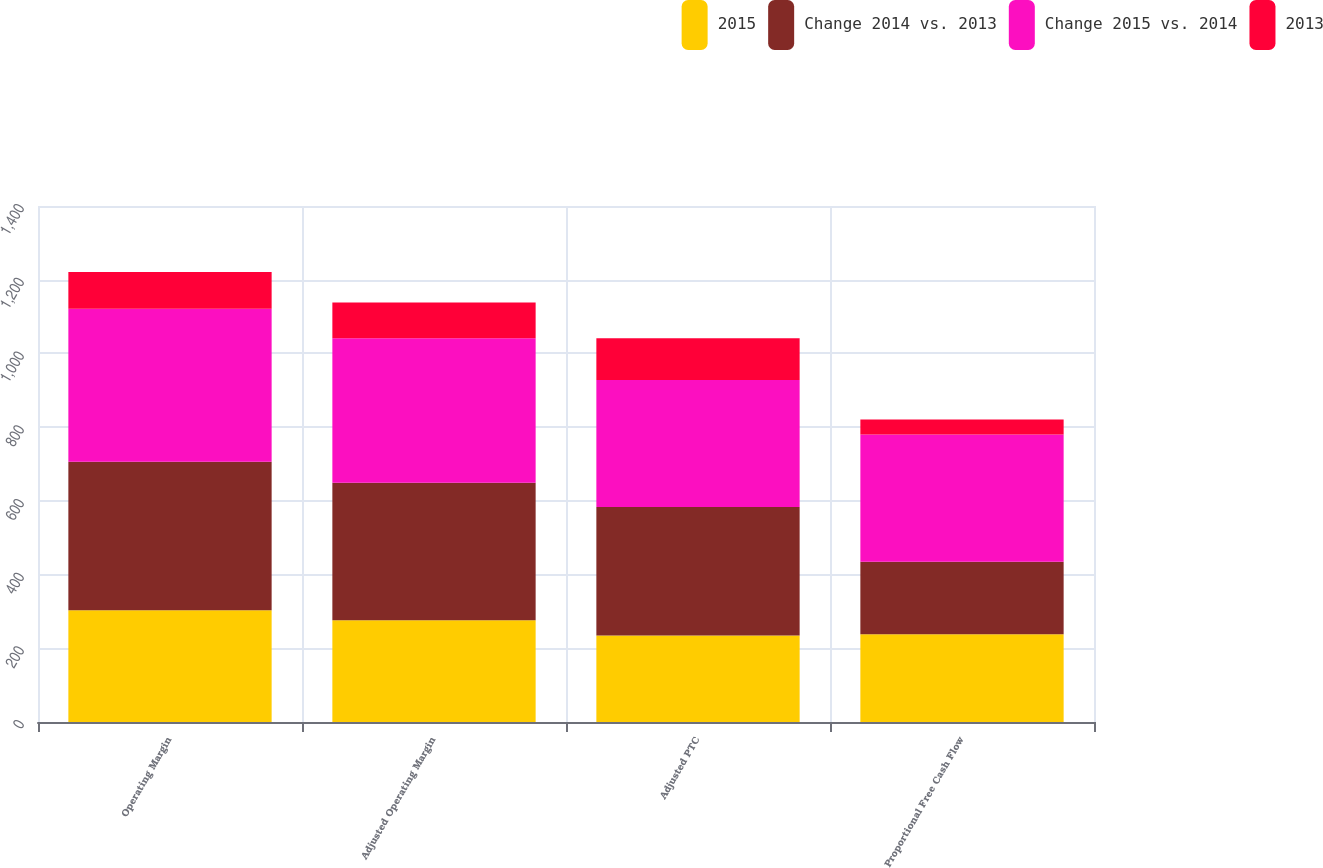Convert chart. <chart><loc_0><loc_0><loc_500><loc_500><stacked_bar_chart><ecel><fcel>Operating Margin<fcel>Adjusted Operating Margin<fcel>Adjusted PTC<fcel>Proportional Free Cash Flow<nl><fcel>2015<fcel>303<fcel>276<fcel>235<fcel>238<nl><fcel>Change 2014 vs. 2013<fcel>403<fcel>373<fcel>348<fcel>197<nl><fcel>Change 2015 vs. 2014<fcel>415<fcel>392<fcel>345<fcel>345<nl><fcel>2013<fcel>100<fcel>97<fcel>113<fcel>41<nl></chart> 